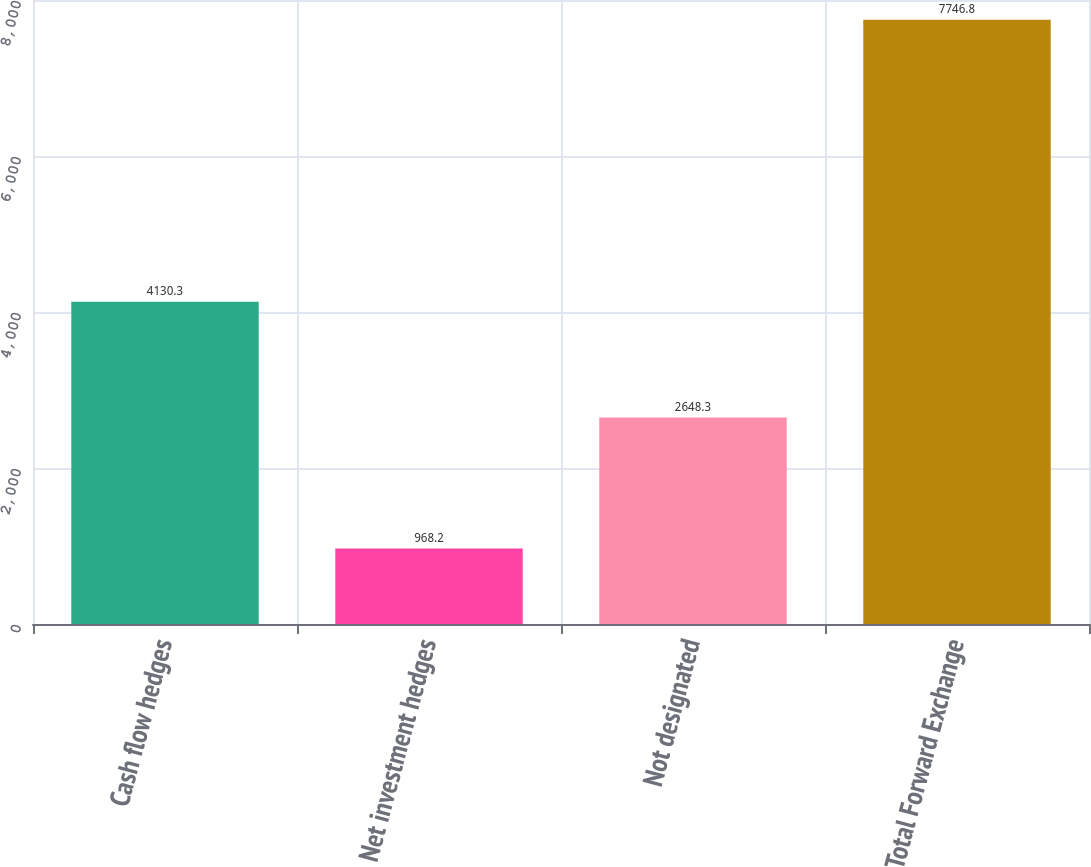Convert chart to OTSL. <chart><loc_0><loc_0><loc_500><loc_500><bar_chart><fcel>Cash flow hedges<fcel>Net investment hedges<fcel>Not designated<fcel>Total Forward Exchange<nl><fcel>4130.3<fcel>968.2<fcel>2648.3<fcel>7746.8<nl></chart> 